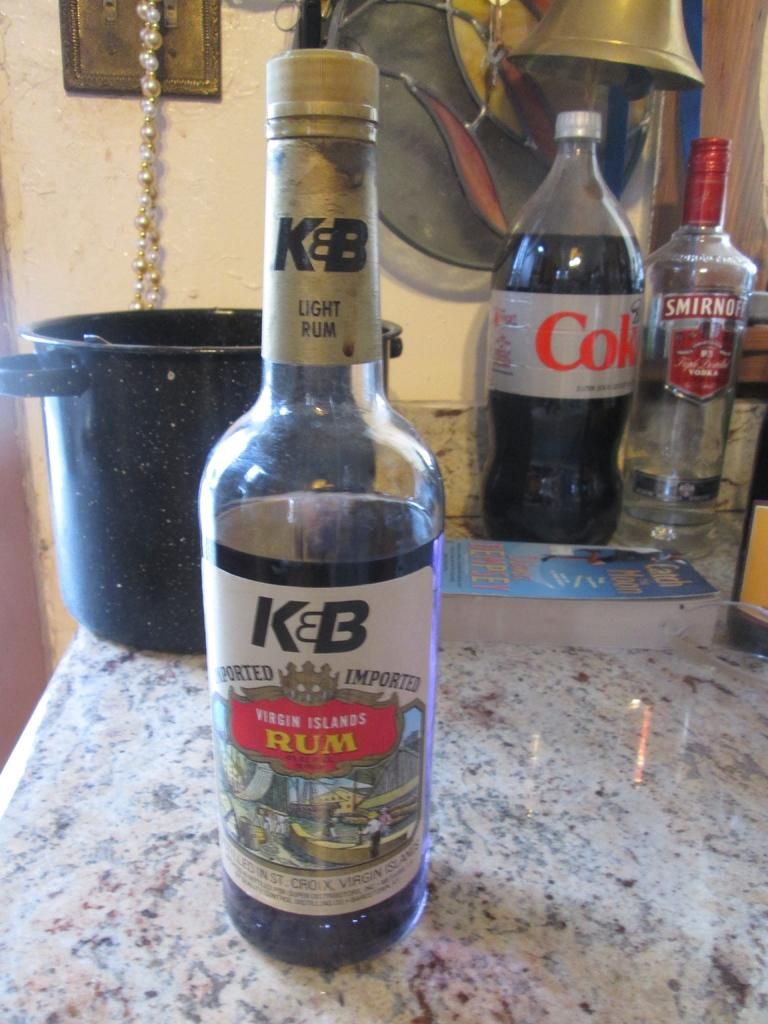<image>
Share a concise interpretation of the image provided. bottle of open rum and coke on the counter 